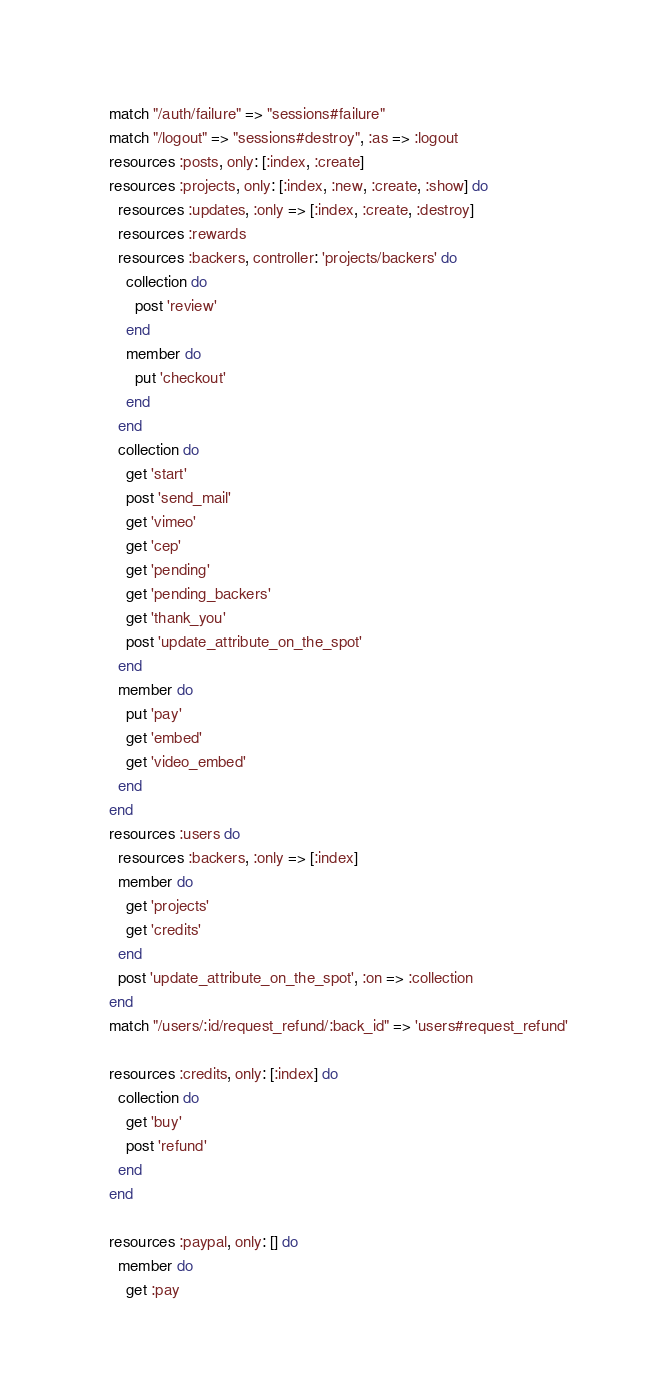<code> <loc_0><loc_0><loc_500><loc_500><_Ruby_>  match "/auth/failure" => "sessions#failure"
  match "/logout" => "sessions#destroy", :as => :logout
  resources :posts, only: [:index, :create]
  resources :projects, only: [:index, :new, :create, :show] do
    resources :updates, :only => [:index, :create, :destroy]
    resources :rewards
    resources :backers, controller: 'projects/backers' do
      collection do
        post 'review'
      end
      member do
        put 'checkout'
      end
    end
    collection do
      get 'start'
      post 'send_mail'
      get 'vimeo'
      get 'cep'
      get 'pending'
      get 'pending_backers'
      get 'thank_you'
      post 'update_attribute_on_the_spot'
    end
    member do
      put 'pay'
      get 'embed'
      get 'video_embed'
    end
  end
  resources :users do
    resources :backers, :only => [:index]
    member do
      get 'projects'
      get 'credits'
    end
    post 'update_attribute_on_the_spot', :on => :collection
  end
  match "/users/:id/request_refund/:back_id" => 'users#request_refund'

  resources :credits, only: [:index] do
    collection do
      get 'buy'
      post 'refund'
    end
  end

  resources :paypal, only: [] do
    member do
      get :pay</code> 